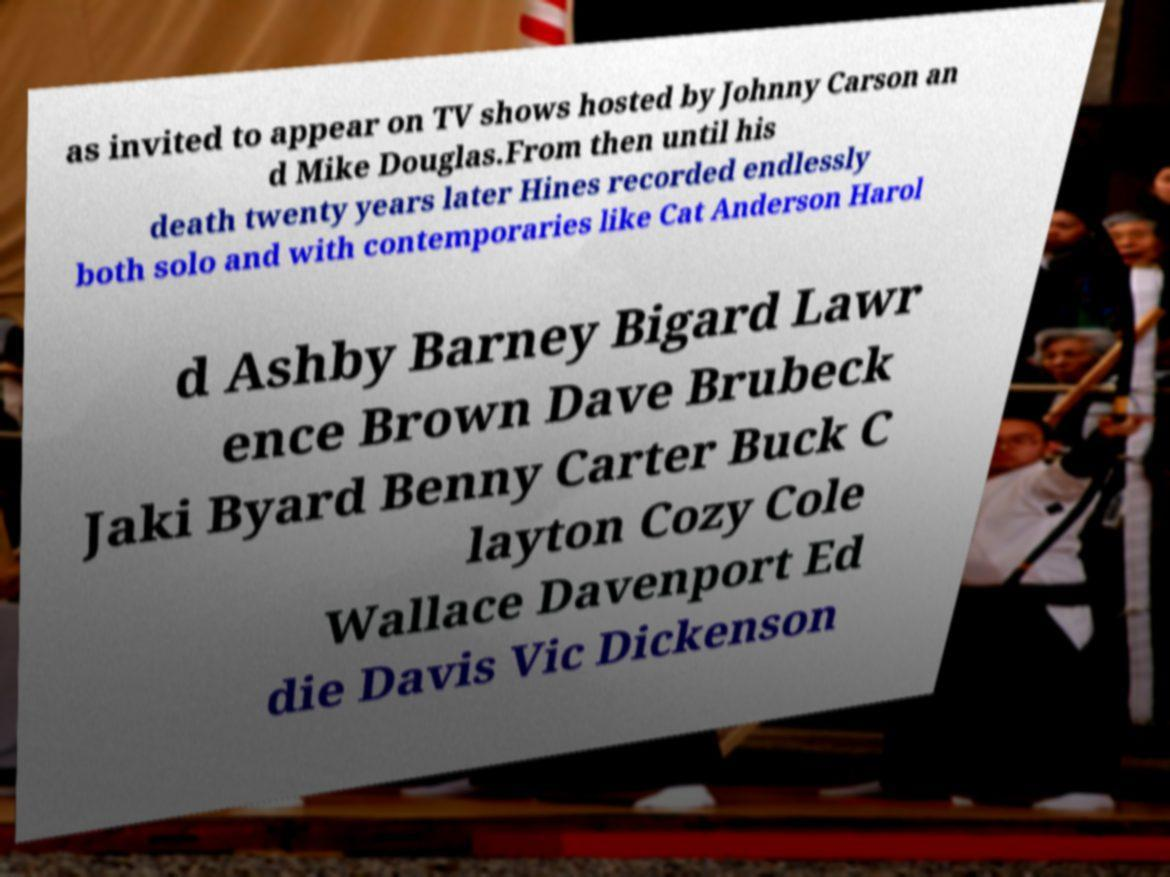I need the written content from this picture converted into text. Can you do that? as invited to appear on TV shows hosted by Johnny Carson an d Mike Douglas.From then until his death twenty years later Hines recorded endlessly both solo and with contemporaries like Cat Anderson Harol d Ashby Barney Bigard Lawr ence Brown Dave Brubeck Jaki Byard Benny Carter Buck C layton Cozy Cole Wallace Davenport Ed die Davis Vic Dickenson 